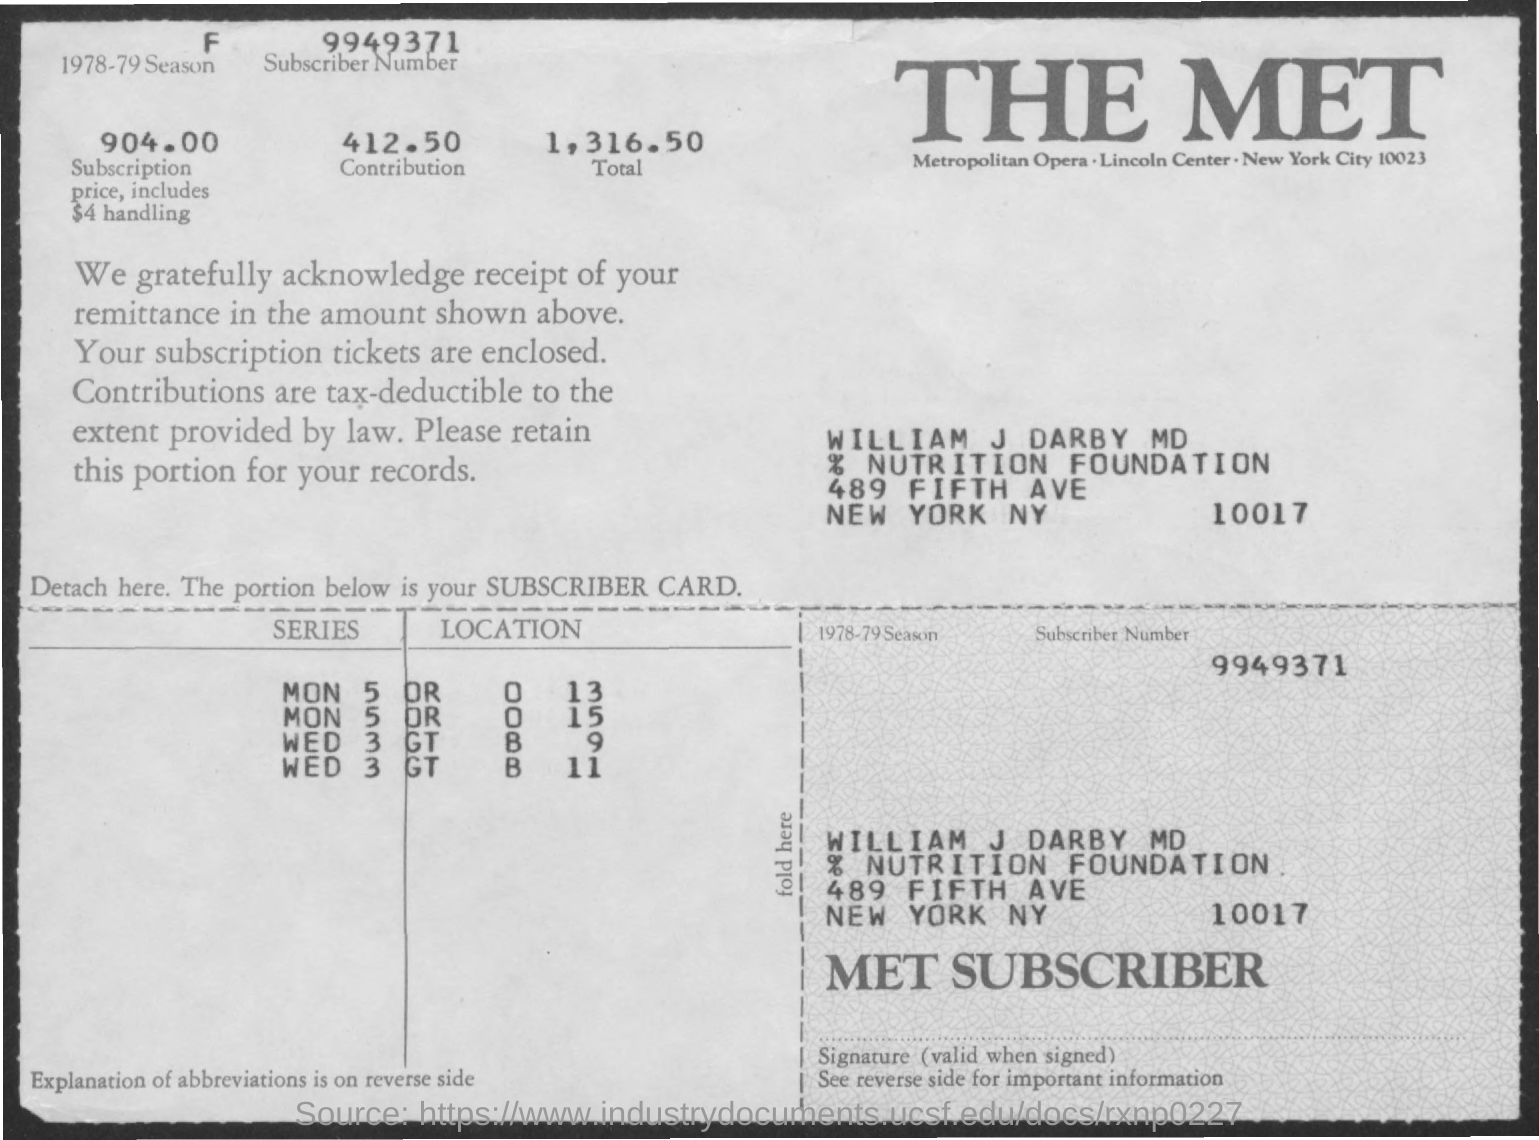Mention a couple of crucial points in this snapshot. The 1978-1979 season was a season in the National Basketball Association (NBA) that took place from October 1978 to April 1979. The subscription price is 904.00. The subscriber of the MET is identified as William J. Darby, MD. The total is 1,316.50. The subscriber number is 9949371.. 